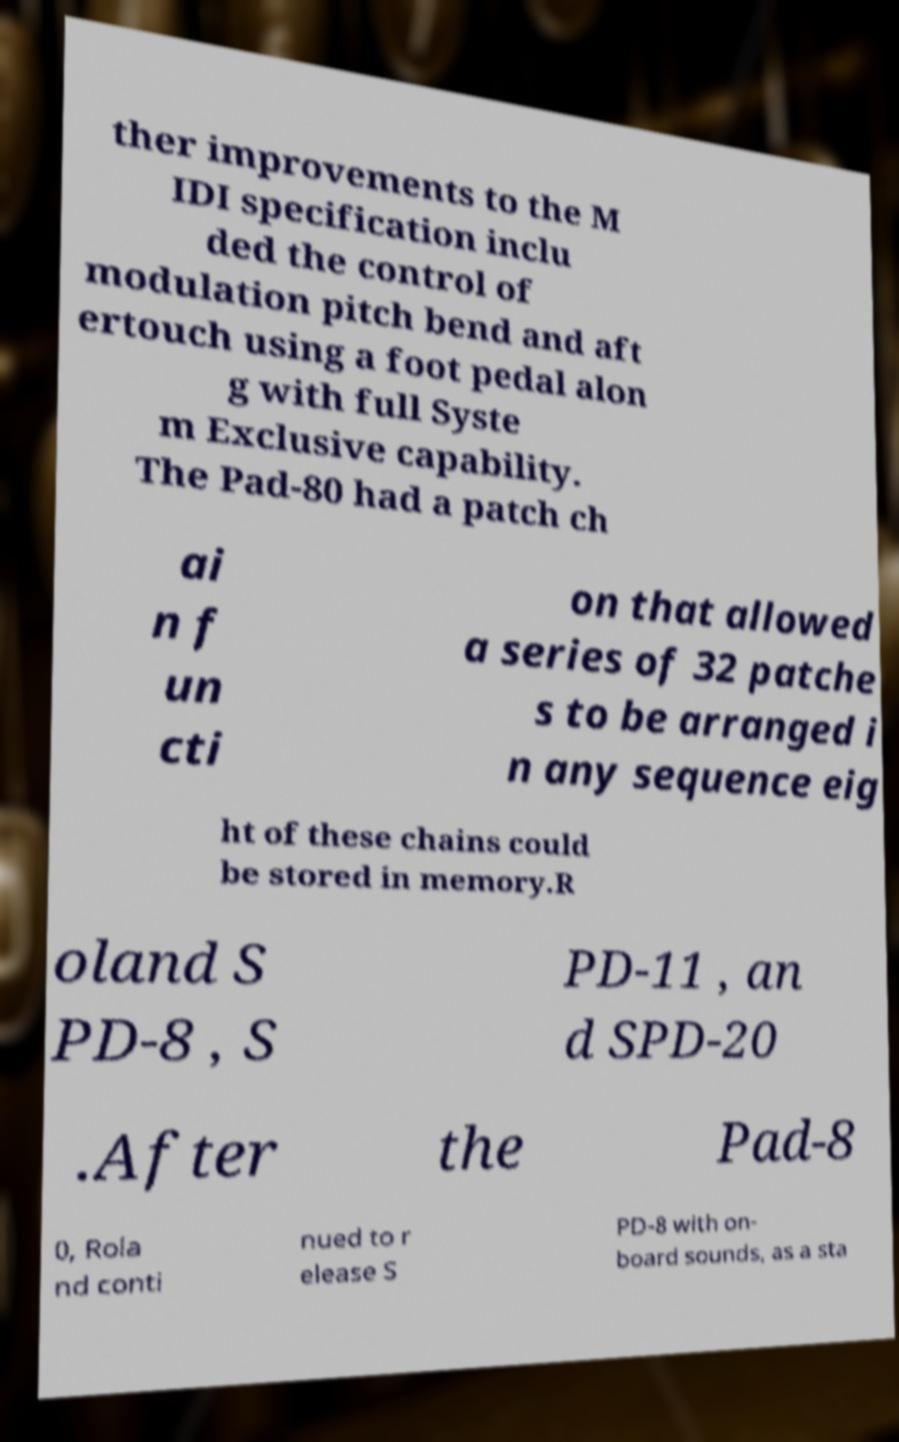For documentation purposes, I need the text within this image transcribed. Could you provide that? ther improvements to the M IDI specification inclu ded the control of modulation pitch bend and aft ertouch using a foot pedal alon g with full Syste m Exclusive capability. The Pad-80 had a patch ch ai n f un cti on that allowed a series of 32 patche s to be arranged i n any sequence eig ht of these chains could be stored in memory.R oland S PD-8 , S PD-11 , an d SPD-20 .After the Pad-8 0, Rola nd conti nued to r elease S PD-8 with on- board sounds, as a sta 